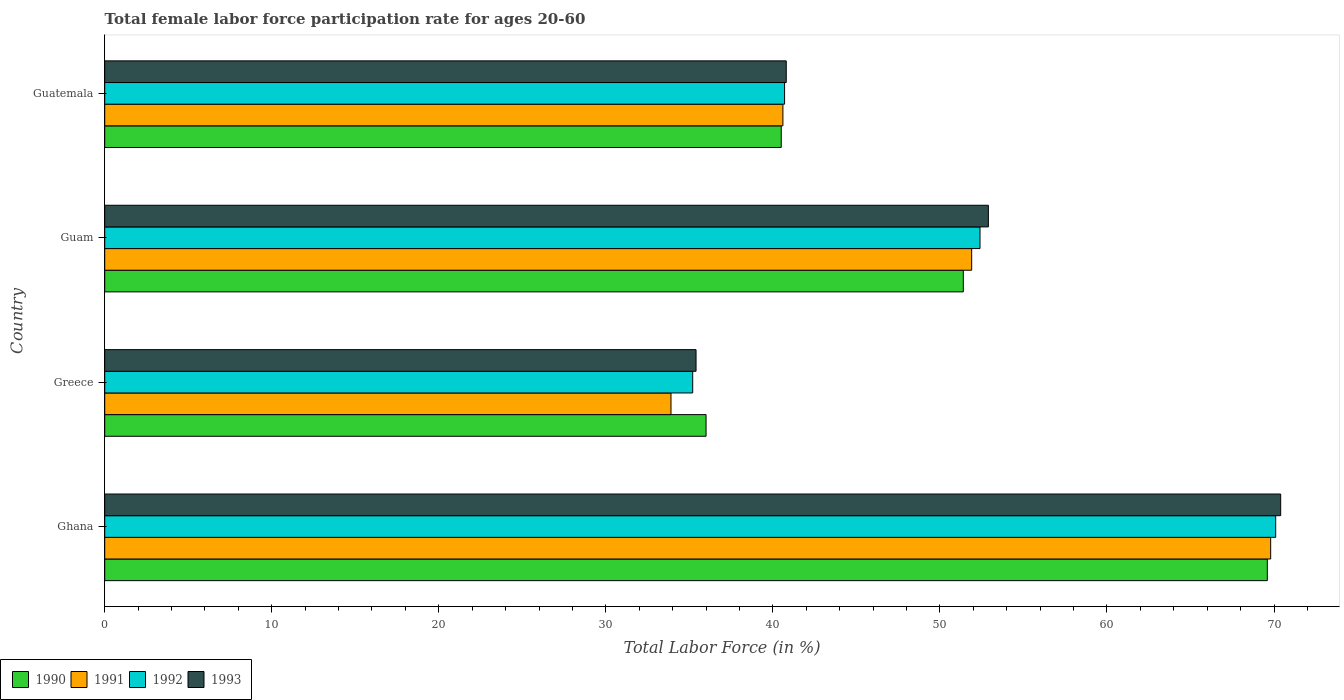Are the number of bars per tick equal to the number of legend labels?
Ensure brevity in your answer.  Yes. Are the number of bars on each tick of the Y-axis equal?
Give a very brief answer. Yes. How many bars are there on the 3rd tick from the top?
Keep it short and to the point. 4. How many bars are there on the 2nd tick from the bottom?
Give a very brief answer. 4. What is the label of the 2nd group of bars from the top?
Your response must be concise. Guam. In how many cases, is the number of bars for a given country not equal to the number of legend labels?
Offer a terse response. 0. What is the female labor force participation rate in 1991 in Guam?
Provide a succinct answer. 51.9. Across all countries, what is the maximum female labor force participation rate in 1992?
Your answer should be compact. 70.1. What is the total female labor force participation rate in 1992 in the graph?
Offer a very short reply. 198.4. What is the difference between the female labor force participation rate in 1990 in Ghana and the female labor force participation rate in 1991 in Guatemala?
Ensure brevity in your answer.  29. What is the average female labor force participation rate in 1990 per country?
Provide a succinct answer. 49.37. What is the difference between the female labor force participation rate in 1990 and female labor force participation rate in 1991 in Guatemala?
Your response must be concise. -0.1. In how many countries, is the female labor force participation rate in 1990 greater than 56 %?
Provide a succinct answer. 1. What is the ratio of the female labor force participation rate in 1993 in Ghana to that in Guatemala?
Your answer should be very brief. 1.73. What is the difference between the highest and the second highest female labor force participation rate in 1991?
Give a very brief answer. 17.9. What is the difference between the highest and the lowest female labor force participation rate in 1990?
Your response must be concise. 33.6. What does the 1st bar from the top in Guam represents?
Your answer should be compact. 1993. How many countries are there in the graph?
Provide a short and direct response. 4. Are the values on the major ticks of X-axis written in scientific E-notation?
Give a very brief answer. No. How many legend labels are there?
Give a very brief answer. 4. How are the legend labels stacked?
Your response must be concise. Horizontal. What is the title of the graph?
Offer a terse response. Total female labor force participation rate for ages 20-60. Does "1961" appear as one of the legend labels in the graph?
Keep it short and to the point. No. What is the label or title of the X-axis?
Offer a very short reply. Total Labor Force (in %). What is the label or title of the Y-axis?
Keep it short and to the point. Country. What is the Total Labor Force (in %) in 1990 in Ghana?
Provide a succinct answer. 69.6. What is the Total Labor Force (in %) of 1991 in Ghana?
Give a very brief answer. 69.8. What is the Total Labor Force (in %) in 1992 in Ghana?
Offer a very short reply. 70.1. What is the Total Labor Force (in %) of 1993 in Ghana?
Your answer should be compact. 70.4. What is the Total Labor Force (in %) in 1991 in Greece?
Provide a short and direct response. 33.9. What is the Total Labor Force (in %) in 1992 in Greece?
Offer a terse response. 35.2. What is the Total Labor Force (in %) in 1993 in Greece?
Your response must be concise. 35.4. What is the Total Labor Force (in %) in 1990 in Guam?
Provide a short and direct response. 51.4. What is the Total Labor Force (in %) of 1991 in Guam?
Offer a very short reply. 51.9. What is the Total Labor Force (in %) in 1992 in Guam?
Provide a succinct answer. 52.4. What is the Total Labor Force (in %) of 1993 in Guam?
Provide a short and direct response. 52.9. What is the Total Labor Force (in %) of 1990 in Guatemala?
Provide a short and direct response. 40.5. What is the Total Labor Force (in %) in 1991 in Guatemala?
Your answer should be compact. 40.6. What is the Total Labor Force (in %) in 1992 in Guatemala?
Your answer should be compact. 40.7. What is the Total Labor Force (in %) of 1993 in Guatemala?
Your answer should be very brief. 40.8. Across all countries, what is the maximum Total Labor Force (in %) in 1990?
Give a very brief answer. 69.6. Across all countries, what is the maximum Total Labor Force (in %) in 1991?
Your answer should be very brief. 69.8. Across all countries, what is the maximum Total Labor Force (in %) of 1992?
Offer a very short reply. 70.1. Across all countries, what is the maximum Total Labor Force (in %) of 1993?
Keep it short and to the point. 70.4. Across all countries, what is the minimum Total Labor Force (in %) of 1991?
Keep it short and to the point. 33.9. Across all countries, what is the minimum Total Labor Force (in %) of 1992?
Offer a very short reply. 35.2. Across all countries, what is the minimum Total Labor Force (in %) of 1993?
Ensure brevity in your answer.  35.4. What is the total Total Labor Force (in %) of 1990 in the graph?
Your answer should be compact. 197.5. What is the total Total Labor Force (in %) in 1991 in the graph?
Offer a terse response. 196.2. What is the total Total Labor Force (in %) of 1992 in the graph?
Your answer should be compact. 198.4. What is the total Total Labor Force (in %) in 1993 in the graph?
Keep it short and to the point. 199.5. What is the difference between the Total Labor Force (in %) of 1990 in Ghana and that in Greece?
Offer a terse response. 33.6. What is the difference between the Total Labor Force (in %) in 1991 in Ghana and that in Greece?
Ensure brevity in your answer.  35.9. What is the difference between the Total Labor Force (in %) of 1992 in Ghana and that in Greece?
Provide a succinct answer. 34.9. What is the difference between the Total Labor Force (in %) of 1990 in Ghana and that in Guam?
Give a very brief answer. 18.2. What is the difference between the Total Labor Force (in %) of 1991 in Ghana and that in Guam?
Provide a short and direct response. 17.9. What is the difference between the Total Labor Force (in %) of 1992 in Ghana and that in Guam?
Offer a terse response. 17.7. What is the difference between the Total Labor Force (in %) in 1990 in Ghana and that in Guatemala?
Provide a succinct answer. 29.1. What is the difference between the Total Labor Force (in %) in 1991 in Ghana and that in Guatemala?
Your answer should be very brief. 29.2. What is the difference between the Total Labor Force (in %) in 1992 in Ghana and that in Guatemala?
Give a very brief answer. 29.4. What is the difference between the Total Labor Force (in %) of 1993 in Ghana and that in Guatemala?
Offer a very short reply. 29.6. What is the difference between the Total Labor Force (in %) of 1990 in Greece and that in Guam?
Offer a terse response. -15.4. What is the difference between the Total Labor Force (in %) of 1992 in Greece and that in Guam?
Provide a succinct answer. -17.2. What is the difference between the Total Labor Force (in %) of 1993 in Greece and that in Guam?
Make the answer very short. -17.5. What is the difference between the Total Labor Force (in %) of 1990 in Greece and that in Guatemala?
Provide a succinct answer. -4.5. What is the difference between the Total Labor Force (in %) of 1992 in Greece and that in Guatemala?
Offer a terse response. -5.5. What is the difference between the Total Labor Force (in %) of 1993 in Greece and that in Guatemala?
Provide a short and direct response. -5.4. What is the difference between the Total Labor Force (in %) in 1990 in Guam and that in Guatemala?
Provide a succinct answer. 10.9. What is the difference between the Total Labor Force (in %) of 1990 in Ghana and the Total Labor Force (in %) of 1991 in Greece?
Offer a very short reply. 35.7. What is the difference between the Total Labor Force (in %) in 1990 in Ghana and the Total Labor Force (in %) in 1992 in Greece?
Provide a succinct answer. 34.4. What is the difference between the Total Labor Force (in %) in 1990 in Ghana and the Total Labor Force (in %) in 1993 in Greece?
Ensure brevity in your answer.  34.2. What is the difference between the Total Labor Force (in %) of 1991 in Ghana and the Total Labor Force (in %) of 1992 in Greece?
Make the answer very short. 34.6. What is the difference between the Total Labor Force (in %) of 1991 in Ghana and the Total Labor Force (in %) of 1993 in Greece?
Offer a very short reply. 34.4. What is the difference between the Total Labor Force (in %) in 1992 in Ghana and the Total Labor Force (in %) in 1993 in Greece?
Give a very brief answer. 34.7. What is the difference between the Total Labor Force (in %) in 1990 in Ghana and the Total Labor Force (in %) in 1991 in Guam?
Offer a terse response. 17.7. What is the difference between the Total Labor Force (in %) of 1990 in Ghana and the Total Labor Force (in %) of 1993 in Guam?
Provide a short and direct response. 16.7. What is the difference between the Total Labor Force (in %) of 1991 in Ghana and the Total Labor Force (in %) of 1993 in Guam?
Make the answer very short. 16.9. What is the difference between the Total Labor Force (in %) in 1990 in Ghana and the Total Labor Force (in %) in 1992 in Guatemala?
Ensure brevity in your answer.  28.9. What is the difference between the Total Labor Force (in %) of 1990 in Ghana and the Total Labor Force (in %) of 1993 in Guatemala?
Offer a very short reply. 28.8. What is the difference between the Total Labor Force (in %) of 1991 in Ghana and the Total Labor Force (in %) of 1992 in Guatemala?
Provide a succinct answer. 29.1. What is the difference between the Total Labor Force (in %) in 1991 in Ghana and the Total Labor Force (in %) in 1993 in Guatemala?
Your answer should be compact. 29. What is the difference between the Total Labor Force (in %) in 1992 in Ghana and the Total Labor Force (in %) in 1993 in Guatemala?
Keep it short and to the point. 29.3. What is the difference between the Total Labor Force (in %) in 1990 in Greece and the Total Labor Force (in %) in 1991 in Guam?
Your answer should be very brief. -15.9. What is the difference between the Total Labor Force (in %) in 1990 in Greece and the Total Labor Force (in %) in 1992 in Guam?
Your response must be concise. -16.4. What is the difference between the Total Labor Force (in %) in 1990 in Greece and the Total Labor Force (in %) in 1993 in Guam?
Keep it short and to the point. -16.9. What is the difference between the Total Labor Force (in %) of 1991 in Greece and the Total Labor Force (in %) of 1992 in Guam?
Provide a succinct answer. -18.5. What is the difference between the Total Labor Force (in %) in 1992 in Greece and the Total Labor Force (in %) in 1993 in Guam?
Your answer should be compact. -17.7. What is the difference between the Total Labor Force (in %) in 1990 in Greece and the Total Labor Force (in %) in 1991 in Guatemala?
Provide a succinct answer. -4.6. What is the difference between the Total Labor Force (in %) in 1990 in Greece and the Total Labor Force (in %) in 1992 in Guatemala?
Provide a short and direct response. -4.7. What is the difference between the Total Labor Force (in %) in 1990 in Greece and the Total Labor Force (in %) in 1993 in Guatemala?
Offer a very short reply. -4.8. What is the difference between the Total Labor Force (in %) in 1991 in Greece and the Total Labor Force (in %) in 1992 in Guatemala?
Give a very brief answer. -6.8. What is the difference between the Total Labor Force (in %) in 1992 in Greece and the Total Labor Force (in %) in 1993 in Guatemala?
Ensure brevity in your answer.  -5.6. What is the difference between the Total Labor Force (in %) in 1990 in Guam and the Total Labor Force (in %) in 1991 in Guatemala?
Keep it short and to the point. 10.8. What is the difference between the Total Labor Force (in %) in 1990 in Guam and the Total Labor Force (in %) in 1992 in Guatemala?
Offer a terse response. 10.7. What is the difference between the Total Labor Force (in %) of 1990 in Guam and the Total Labor Force (in %) of 1993 in Guatemala?
Your response must be concise. 10.6. What is the difference between the Total Labor Force (in %) in 1991 in Guam and the Total Labor Force (in %) in 1993 in Guatemala?
Keep it short and to the point. 11.1. What is the average Total Labor Force (in %) of 1990 per country?
Your response must be concise. 49.38. What is the average Total Labor Force (in %) of 1991 per country?
Your answer should be very brief. 49.05. What is the average Total Labor Force (in %) in 1992 per country?
Offer a terse response. 49.6. What is the average Total Labor Force (in %) in 1993 per country?
Your answer should be very brief. 49.88. What is the difference between the Total Labor Force (in %) of 1990 and Total Labor Force (in %) of 1991 in Ghana?
Offer a very short reply. -0.2. What is the difference between the Total Labor Force (in %) of 1990 and Total Labor Force (in %) of 1992 in Ghana?
Offer a terse response. -0.5. What is the difference between the Total Labor Force (in %) of 1991 and Total Labor Force (in %) of 1993 in Ghana?
Provide a succinct answer. -0.6. What is the difference between the Total Labor Force (in %) of 1990 and Total Labor Force (in %) of 1991 in Greece?
Your response must be concise. 2.1. What is the difference between the Total Labor Force (in %) in 1990 and Total Labor Force (in %) in 1992 in Greece?
Your answer should be compact. 0.8. What is the difference between the Total Labor Force (in %) of 1990 and Total Labor Force (in %) of 1993 in Greece?
Make the answer very short. 0.6. What is the difference between the Total Labor Force (in %) of 1991 and Total Labor Force (in %) of 1992 in Greece?
Ensure brevity in your answer.  -1.3. What is the difference between the Total Labor Force (in %) of 1991 and Total Labor Force (in %) of 1993 in Greece?
Keep it short and to the point. -1.5. What is the difference between the Total Labor Force (in %) of 1991 and Total Labor Force (in %) of 1992 in Guam?
Provide a succinct answer. -0.5. What is the difference between the Total Labor Force (in %) of 1992 and Total Labor Force (in %) of 1993 in Guam?
Your answer should be compact. -0.5. What is the difference between the Total Labor Force (in %) of 1990 and Total Labor Force (in %) of 1993 in Guatemala?
Provide a succinct answer. -0.3. What is the difference between the Total Labor Force (in %) in 1991 and Total Labor Force (in %) in 1992 in Guatemala?
Provide a succinct answer. -0.1. What is the ratio of the Total Labor Force (in %) in 1990 in Ghana to that in Greece?
Make the answer very short. 1.93. What is the ratio of the Total Labor Force (in %) in 1991 in Ghana to that in Greece?
Provide a succinct answer. 2.06. What is the ratio of the Total Labor Force (in %) in 1992 in Ghana to that in Greece?
Offer a very short reply. 1.99. What is the ratio of the Total Labor Force (in %) in 1993 in Ghana to that in Greece?
Give a very brief answer. 1.99. What is the ratio of the Total Labor Force (in %) of 1990 in Ghana to that in Guam?
Give a very brief answer. 1.35. What is the ratio of the Total Labor Force (in %) in 1991 in Ghana to that in Guam?
Give a very brief answer. 1.34. What is the ratio of the Total Labor Force (in %) of 1992 in Ghana to that in Guam?
Offer a terse response. 1.34. What is the ratio of the Total Labor Force (in %) in 1993 in Ghana to that in Guam?
Offer a very short reply. 1.33. What is the ratio of the Total Labor Force (in %) in 1990 in Ghana to that in Guatemala?
Your response must be concise. 1.72. What is the ratio of the Total Labor Force (in %) in 1991 in Ghana to that in Guatemala?
Make the answer very short. 1.72. What is the ratio of the Total Labor Force (in %) in 1992 in Ghana to that in Guatemala?
Your answer should be very brief. 1.72. What is the ratio of the Total Labor Force (in %) of 1993 in Ghana to that in Guatemala?
Provide a succinct answer. 1.73. What is the ratio of the Total Labor Force (in %) of 1990 in Greece to that in Guam?
Your answer should be very brief. 0.7. What is the ratio of the Total Labor Force (in %) in 1991 in Greece to that in Guam?
Your response must be concise. 0.65. What is the ratio of the Total Labor Force (in %) in 1992 in Greece to that in Guam?
Your response must be concise. 0.67. What is the ratio of the Total Labor Force (in %) in 1993 in Greece to that in Guam?
Offer a terse response. 0.67. What is the ratio of the Total Labor Force (in %) in 1990 in Greece to that in Guatemala?
Provide a succinct answer. 0.89. What is the ratio of the Total Labor Force (in %) of 1991 in Greece to that in Guatemala?
Ensure brevity in your answer.  0.83. What is the ratio of the Total Labor Force (in %) of 1992 in Greece to that in Guatemala?
Provide a succinct answer. 0.86. What is the ratio of the Total Labor Force (in %) of 1993 in Greece to that in Guatemala?
Your answer should be very brief. 0.87. What is the ratio of the Total Labor Force (in %) of 1990 in Guam to that in Guatemala?
Ensure brevity in your answer.  1.27. What is the ratio of the Total Labor Force (in %) in 1991 in Guam to that in Guatemala?
Your answer should be very brief. 1.28. What is the ratio of the Total Labor Force (in %) in 1992 in Guam to that in Guatemala?
Your answer should be compact. 1.29. What is the ratio of the Total Labor Force (in %) of 1993 in Guam to that in Guatemala?
Keep it short and to the point. 1.3. What is the difference between the highest and the second highest Total Labor Force (in %) in 1990?
Your response must be concise. 18.2. What is the difference between the highest and the second highest Total Labor Force (in %) of 1991?
Ensure brevity in your answer.  17.9. What is the difference between the highest and the second highest Total Labor Force (in %) in 1992?
Offer a terse response. 17.7. What is the difference between the highest and the second highest Total Labor Force (in %) in 1993?
Provide a succinct answer. 17.5. What is the difference between the highest and the lowest Total Labor Force (in %) of 1990?
Provide a short and direct response. 33.6. What is the difference between the highest and the lowest Total Labor Force (in %) of 1991?
Your answer should be compact. 35.9. What is the difference between the highest and the lowest Total Labor Force (in %) in 1992?
Your response must be concise. 34.9. 